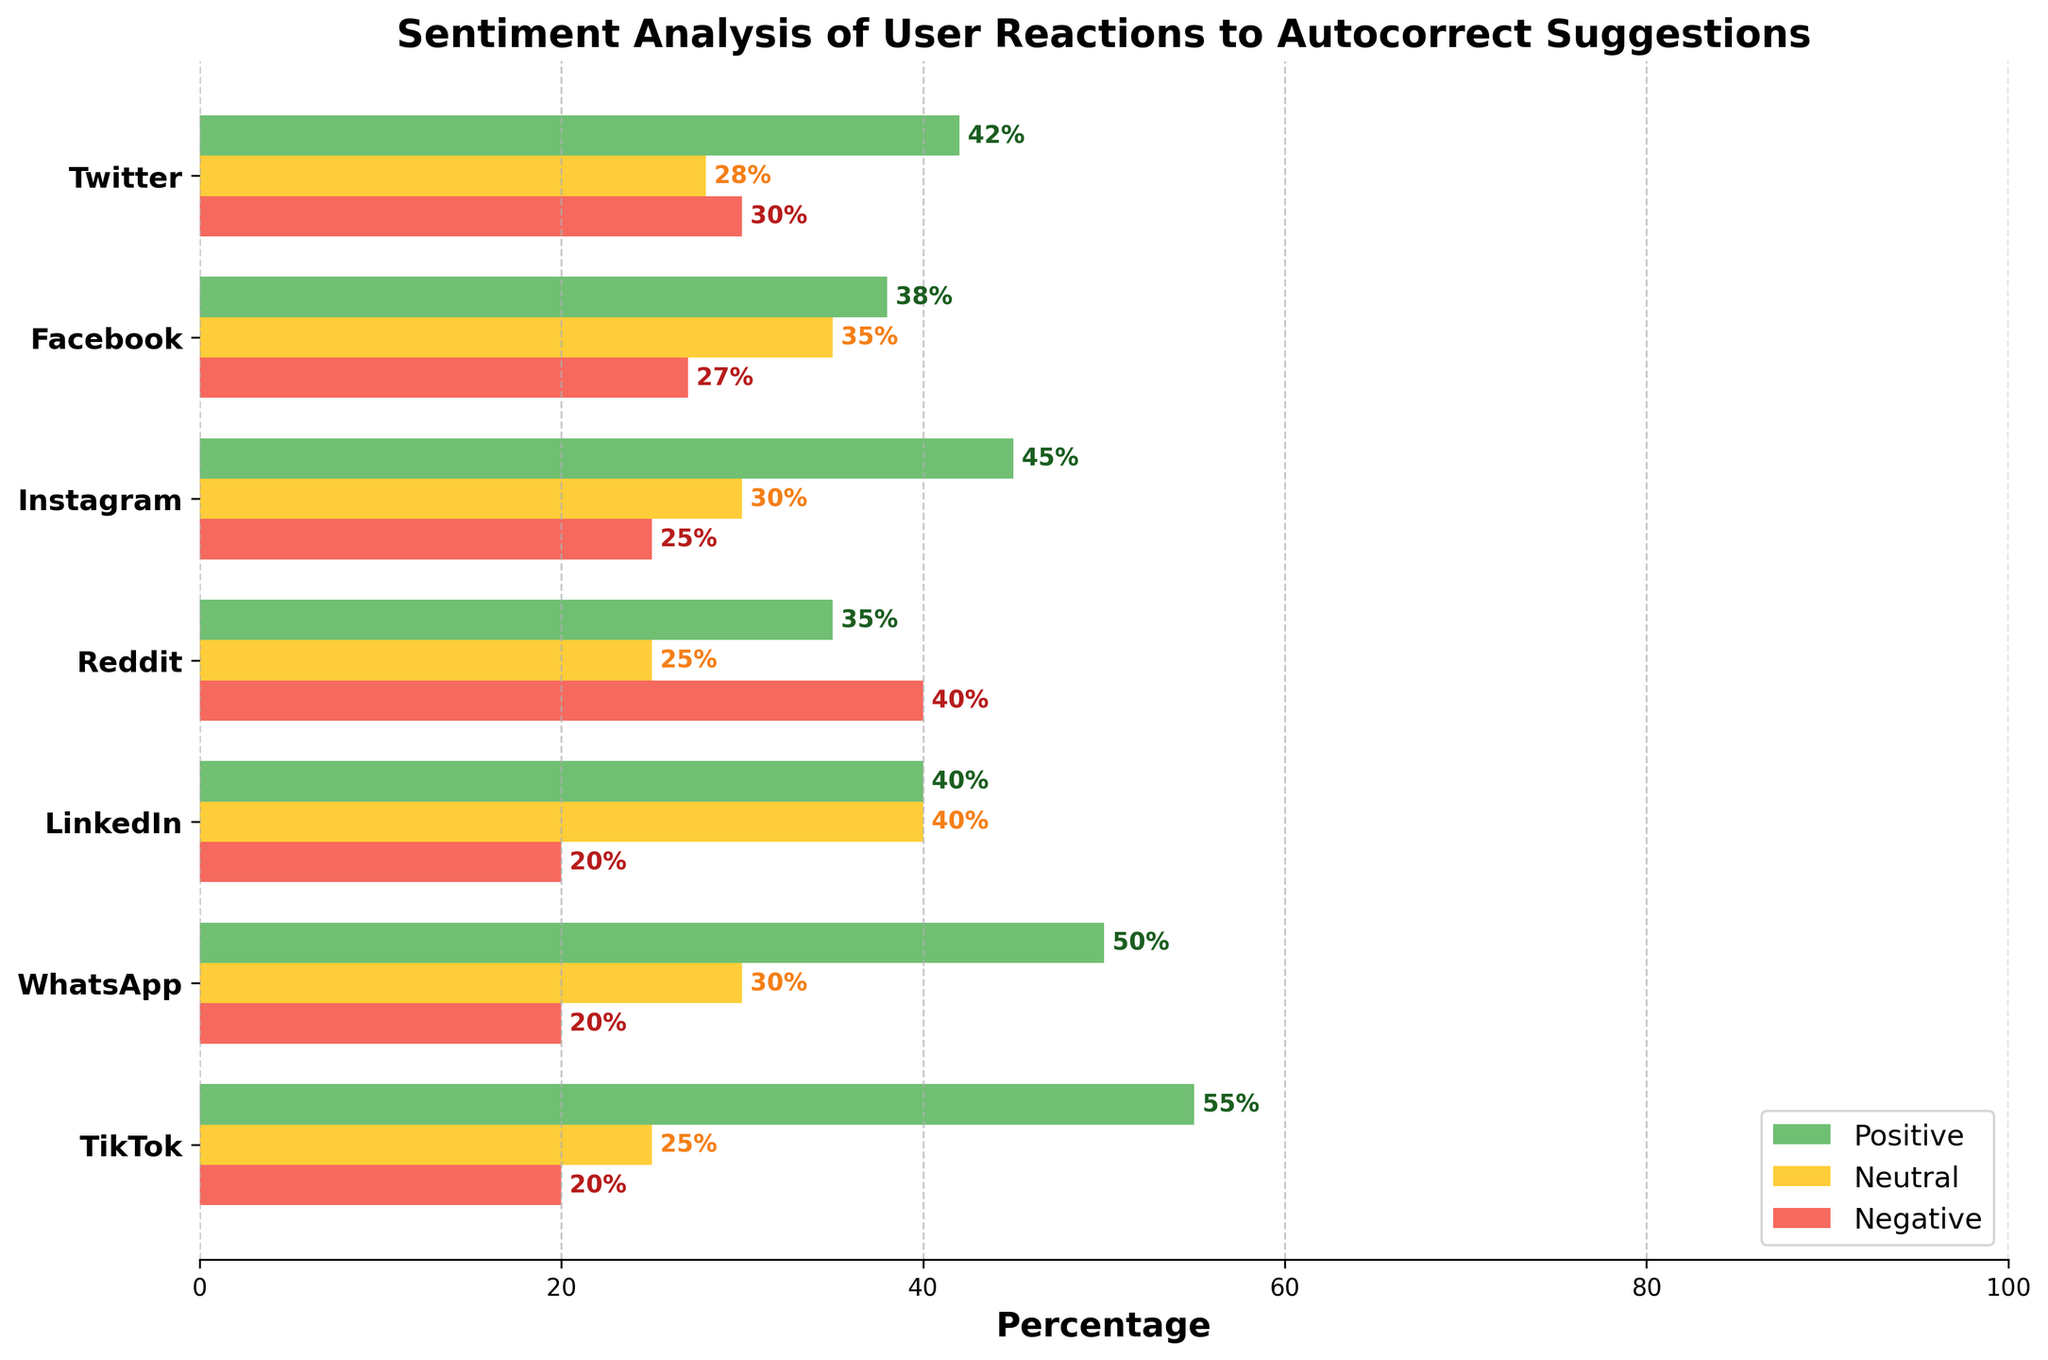What is the title of the plot? The title of the plot is located at the top and is usually a larger, bold text summarizing the content. The title here is "Sentiment Analysis of User Reactions to Autocorrect Suggestions."
Answer: Sentiment Analysis of User Reactions to Autocorrect Suggestions Which platform has the highest percentage of positive reactions? To determine the platform with the highest percentage of positive reactions, look at the green (positive) bars and find the longest one. TikTok has the longest green bar at 55%.
Answer: TikTok Which platform has the most neutral reactions, and what is its percentage? To find the platform with the most neutral reactions, find the longest yellow (neutral) bar. LinkedIn has the longest neutral bar at 40%.
Answer: LinkedIn, 40% What are the negative reaction percentages for Reddit and WhatsApp? To get the negative reaction percentages for Reddit and WhatsApp, locate the red (negative) bars for these platforms. Reddit's negative percentage is 40%, and WhatsApp's is 20%.
Answer: Reddit: 40%, WhatsApp: 20% Which platforms have more neutral reactions than negative reactions? Compare the lengths (percentages) of the yellow (neutral) and red (negative) bars for each platform. Platforms where the yellow bar is longer than the red bar are Facebook, LinkedIn, and WhatsApp.
Answer: Facebook, LinkedIn, WhatsApp What is the difference in positive reactions between Twitter and Instagram? Find the positive reaction percentages for both Twitter (42%) and Instagram (45%). The difference is calculated as 45% - 42% = 3%.
Answer: 3% Which platform has the smallest positive-to-negative reaction ratio? Determine the ratio of positive reactions to negative reactions for each platform and find the smallest:
Twitter: 42/30 = 1.4 
Facebook: 38/27 ≈ 1.41 
Instagram: 45/25 = 1.8 
Reddit: 35/40 = 0.875 
LinkedIn: 40/20 = 2 
WhatsApp: 50/20 = 2.5 
TikTok: 55/20 = 2.75. 
The smallest ratio is on Reddit.
Answer: Reddit What is the average percentage of positive reactions across all platforms? Sum the positive reaction percentages and divide by the number of platforms. (42 + 38 + 45 + 35 + 40 + 50 + 55) / 7 = 43.57 ≈ 43.6%.
Answer: 43.6% Which three platforms have the highest combined percentage of positive and negative reactions? Calculate the sum of positive and negative reactions for each platform and select the top three:
Twitter: 42 + 30 = 72 
Facebook: 38 + 27 = 65 
Instagram: 45 + 25 = 70 
Reddit: 35 + 40 = 75 
LinkedIn: 40 + 20 = 60 
WhatsApp: 50 + 20 = 70 
TikTok: 55 + 20 = 75. 
The top three are Reddit (75), TikTok (75), and Twitter (72).
Answer: Reddit, TikTok, Twitter 